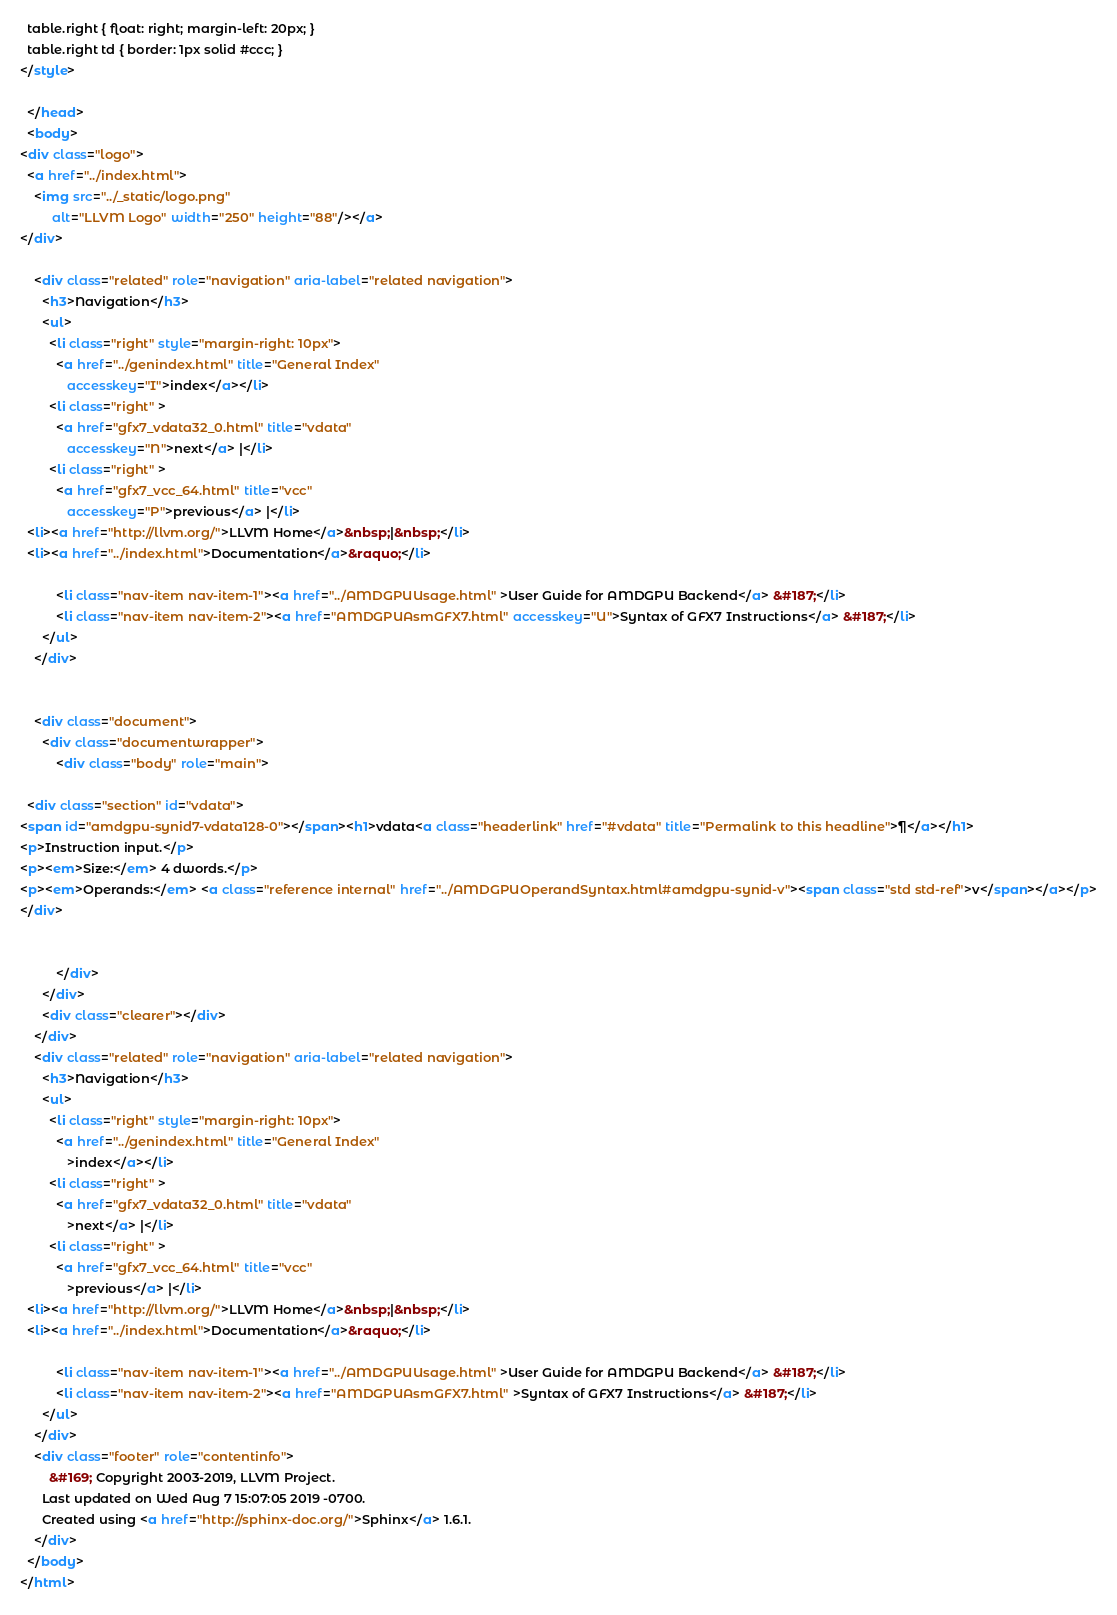<code> <loc_0><loc_0><loc_500><loc_500><_HTML_>  table.right { float: right; margin-left: 20px; }
  table.right td { border: 1px solid #ccc; }
</style>

  </head>
  <body>
<div class="logo">
  <a href="../index.html">
    <img src="../_static/logo.png"
         alt="LLVM Logo" width="250" height="88"/></a>
</div>

    <div class="related" role="navigation" aria-label="related navigation">
      <h3>Navigation</h3>
      <ul>
        <li class="right" style="margin-right: 10px">
          <a href="../genindex.html" title="General Index"
             accesskey="I">index</a></li>
        <li class="right" >
          <a href="gfx7_vdata32_0.html" title="vdata"
             accesskey="N">next</a> |</li>
        <li class="right" >
          <a href="gfx7_vcc_64.html" title="vcc"
             accesskey="P">previous</a> |</li>
  <li><a href="http://llvm.org/">LLVM Home</a>&nbsp;|&nbsp;</li>
  <li><a href="../index.html">Documentation</a>&raquo;</li>

          <li class="nav-item nav-item-1"><a href="../AMDGPUUsage.html" >User Guide for AMDGPU Backend</a> &#187;</li>
          <li class="nav-item nav-item-2"><a href="AMDGPUAsmGFX7.html" accesskey="U">Syntax of GFX7 Instructions</a> &#187;</li> 
      </ul>
    </div>


    <div class="document">
      <div class="documentwrapper">
          <div class="body" role="main">
            
  <div class="section" id="vdata">
<span id="amdgpu-synid7-vdata128-0"></span><h1>vdata<a class="headerlink" href="#vdata" title="Permalink to this headline">¶</a></h1>
<p>Instruction input.</p>
<p><em>Size:</em> 4 dwords.</p>
<p><em>Operands:</em> <a class="reference internal" href="../AMDGPUOperandSyntax.html#amdgpu-synid-v"><span class="std std-ref">v</span></a></p>
</div>


          </div>
      </div>
      <div class="clearer"></div>
    </div>
    <div class="related" role="navigation" aria-label="related navigation">
      <h3>Navigation</h3>
      <ul>
        <li class="right" style="margin-right: 10px">
          <a href="../genindex.html" title="General Index"
             >index</a></li>
        <li class="right" >
          <a href="gfx7_vdata32_0.html" title="vdata"
             >next</a> |</li>
        <li class="right" >
          <a href="gfx7_vcc_64.html" title="vcc"
             >previous</a> |</li>
  <li><a href="http://llvm.org/">LLVM Home</a>&nbsp;|&nbsp;</li>
  <li><a href="../index.html">Documentation</a>&raquo;</li>

          <li class="nav-item nav-item-1"><a href="../AMDGPUUsage.html" >User Guide for AMDGPU Backend</a> &#187;</li>
          <li class="nav-item nav-item-2"><a href="AMDGPUAsmGFX7.html" >Syntax of GFX7 Instructions</a> &#187;</li> 
      </ul>
    </div>
    <div class="footer" role="contentinfo">
        &#169; Copyright 2003-2019, LLVM Project.
      Last updated on Wed Aug 7 15:07:05 2019 -0700.
      Created using <a href="http://sphinx-doc.org/">Sphinx</a> 1.6.1.
    </div>
  </body>
</html></code> 